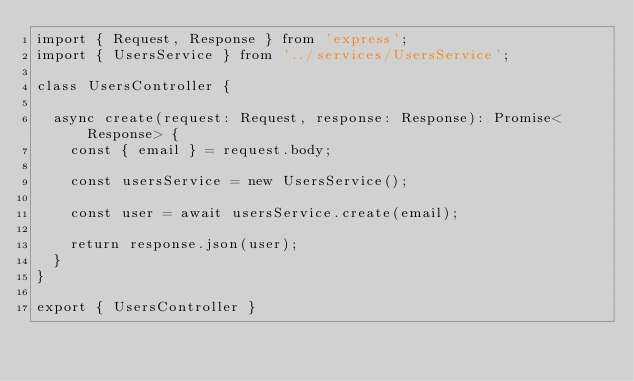Convert code to text. <code><loc_0><loc_0><loc_500><loc_500><_TypeScript_>import { Request, Response } from 'express';
import { UsersService } from '../services/UsersService';

class UsersController {

  async create(request: Request, response: Response): Promise<Response> {
    const { email } = request.body;

    const usersService = new UsersService();

    const user = await usersService.create(email);

    return response.json(user);
  }
}

export { UsersController }</code> 